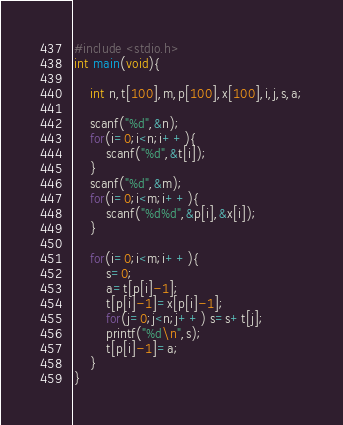<code> <loc_0><loc_0><loc_500><loc_500><_C_>#include <stdio.h>
int main(void){
    
    int n,t[100],m,p[100],x[100],i,j,s,a;
    
    scanf("%d",&n);
    for(i=0;i<n;i++){
        scanf("%d",&t[i]);
    }
    scanf("%d",&m);
    for(i=0;i<m;i++){
        scanf("%d%d",&p[i],&x[i]);
    }
    
    for(i=0;i<m;i++){
        s=0;
        a=t[p[i]-1];
        t[p[i]-1]=x[p[i]-1];
        for(j=0;j<n;j++) s=s+t[j];
        printf("%d\n",s);
        t[p[i]-1]=a;
    } 
}
</code> 